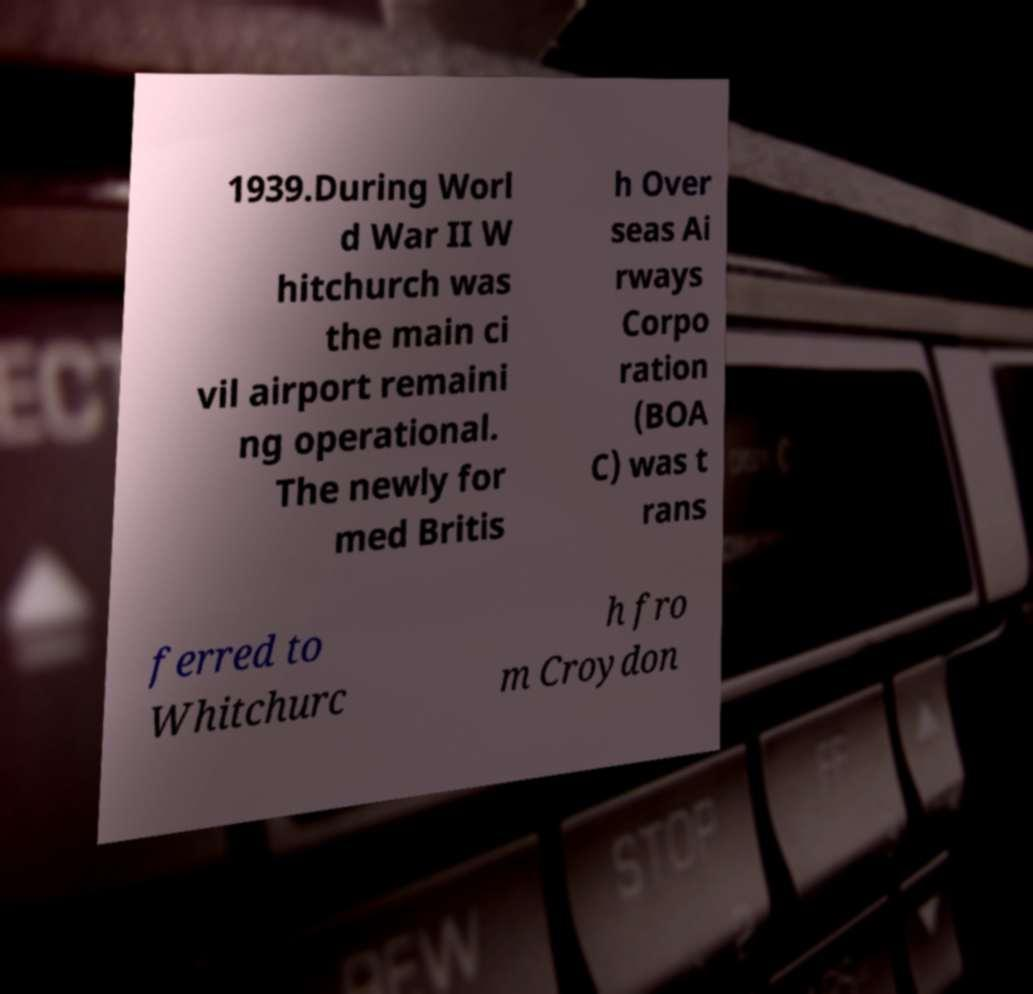There's text embedded in this image that I need extracted. Can you transcribe it verbatim? 1939.During Worl d War II W hitchurch was the main ci vil airport remaini ng operational. The newly for med Britis h Over seas Ai rways Corpo ration (BOA C) was t rans ferred to Whitchurc h fro m Croydon 